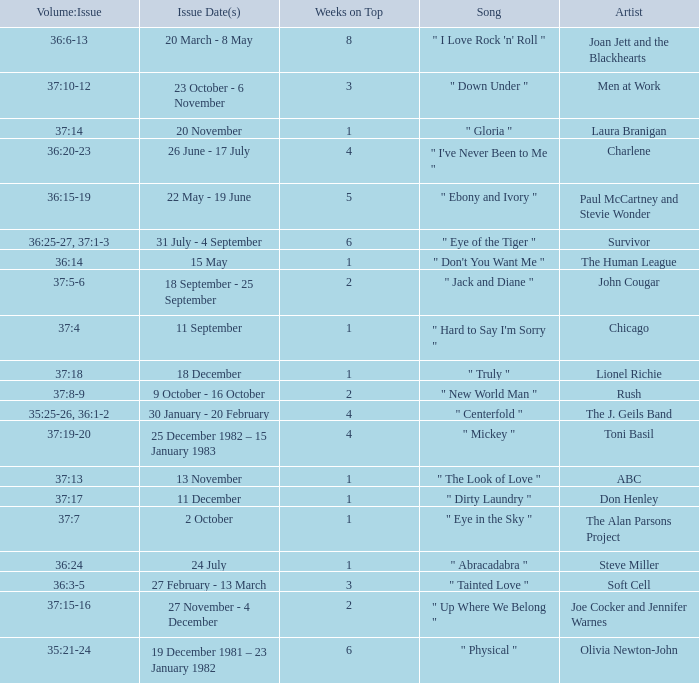Which Weeks on Top have an Issue Date(s) of 20 november? 1.0. 